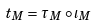Convert formula to latex. <formula><loc_0><loc_0><loc_500><loc_500>t _ { M } = \tau _ { M } \circ \iota _ { M }</formula> 